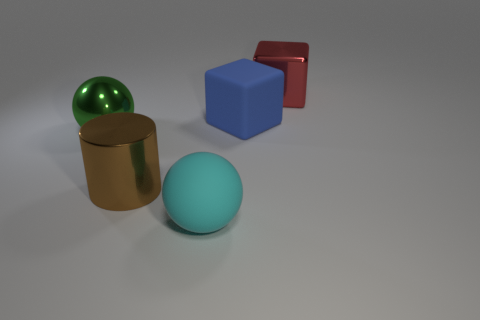There is another thing that is the same shape as the large cyan rubber thing; what is its color?
Your answer should be compact. Green. The large sphere that is made of the same material as the red thing is what color?
Your answer should be compact. Green. How many red blocks are made of the same material as the big green sphere?
Ensure brevity in your answer.  1. What number of things are either small green metallic blocks or big red metal things that are right of the cyan sphere?
Make the answer very short. 1. Is the material of the block in front of the large metallic cube the same as the big green sphere?
Your answer should be very brief. No. What is the color of the rubber sphere that is the same size as the green object?
Your response must be concise. Cyan. Is there a purple metallic object of the same shape as the cyan matte object?
Ensure brevity in your answer.  No. There is a metallic thing that is behind the rubber thing that is on the right side of the sphere that is right of the brown object; what is its color?
Provide a short and direct response. Red. What number of rubber objects are either large blue cubes or big gray balls?
Your answer should be compact. 1. Is the number of blue matte blocks in front of the large brown thing greater than the number of big red blocks on the right side of the big red object?
Keep it short and to the point. No. 